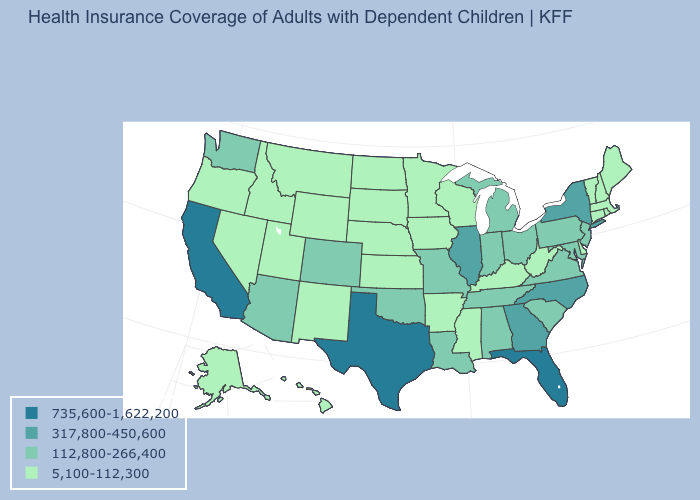Does the map have missing data?
Write a very short answer. No. What is the value of Rhode Island?
Give a very brief answer. 5,100-112,300. Is the legend a continuous bar?
Short answer required. No. Which states hav the highest value in the West?
Give a very brief answer. California. Does Texas have the highest value in the South?
Write a very short answer. Yes. What is the value of Arkansas?
Answer briefly. 5,100-112,300. Name the states that have a value in the range 112,800-266,400?
Answer briefly. Alabama, Arizona, Colorado, Indiana, Louisiana, Maryland, Michigan, Missouri, New Jersey, Ohio, Oklahoma, Pennsylvania, South Carolina, Tennessee, Virginia, Washington. Name the states that have a value in the range 735,600-1,622,200?
Answer briefly. California, Florida, Texas. Which states have the highest value in the USA?
Quick response, please. California, Florida, Texas. What is the value of Alabama?
Give a very brief answer. 112,800-266,400. Which states have the highest value in the USA?
Short answer required. California, Florida, Texas. Name the states that have a value in the range 735,600-1,622,200?
Short answer required. California, Florida, Texas. Name the states that have a value in the range 735,600-1,622,200?
Be succinct. California, Florida, Texas. Name the states that have a value in the range 735,600-1,622,200?
Answer briefly. California, Florida, Texas. Name the states that have a value in the range 735,600-1,622,200?
Concise answer only. California, Florida, Texas. 